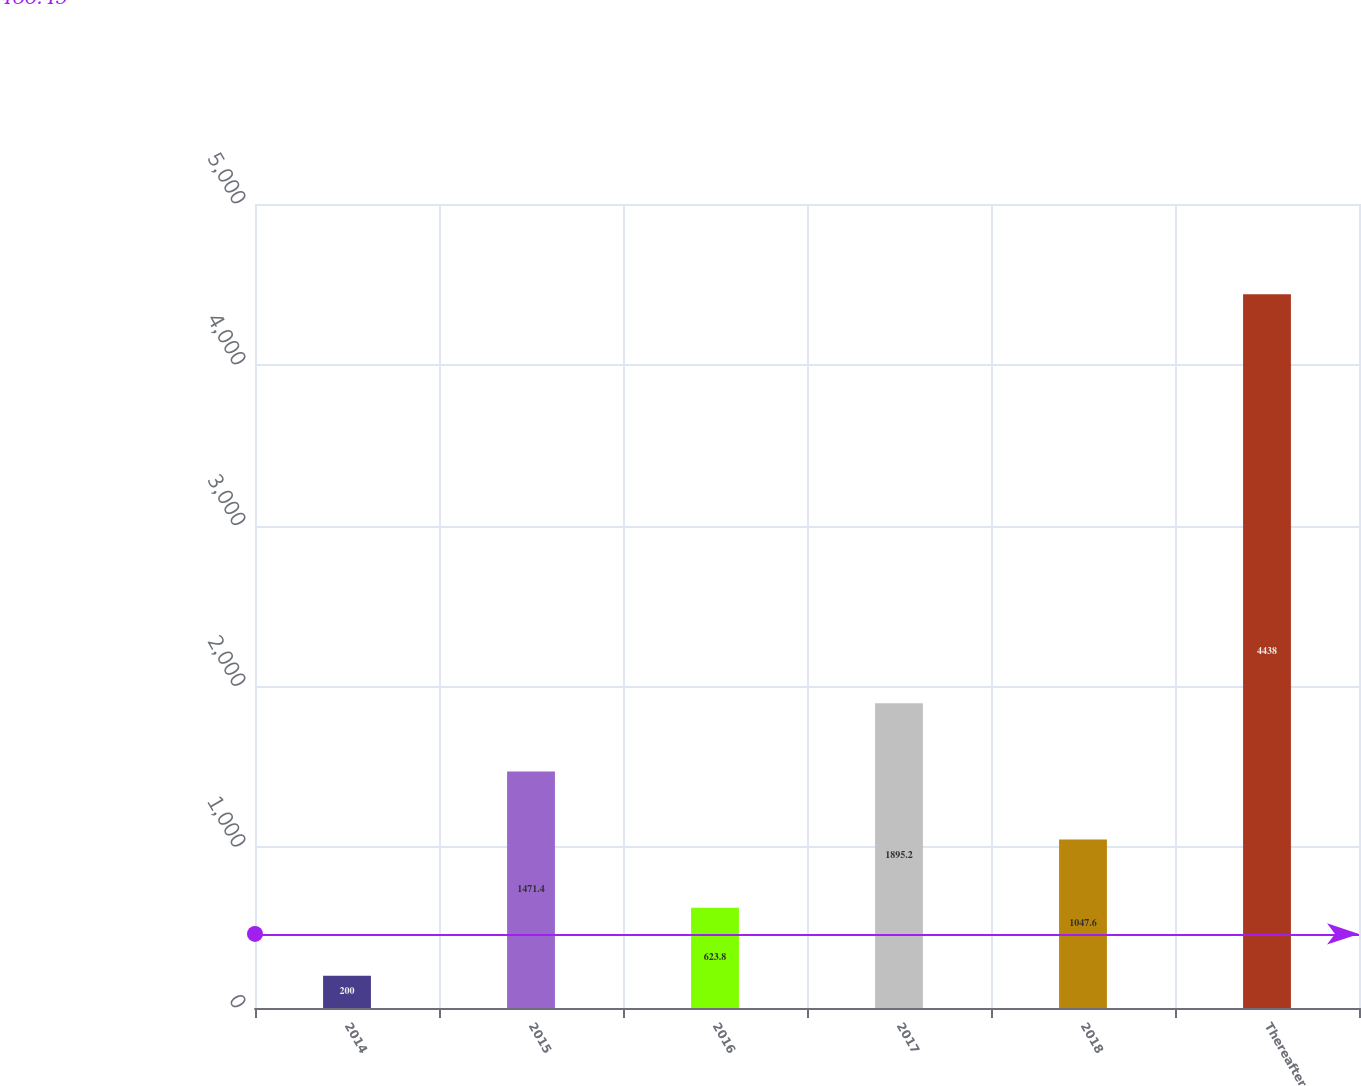Convert chart to OTSL. <chart><loc_0><loc_0><loc_500><loc_500><bar_chart><fcel>2014<fcel>2015<fcel>2016<fcel>2017<fcel>2018<fcel>Thereafter<nl><fcel>200<fcel>1471.4<fcel>623.8<fcel>1895.2<fcel>1047.6<fcel>4438<nl></chart> 